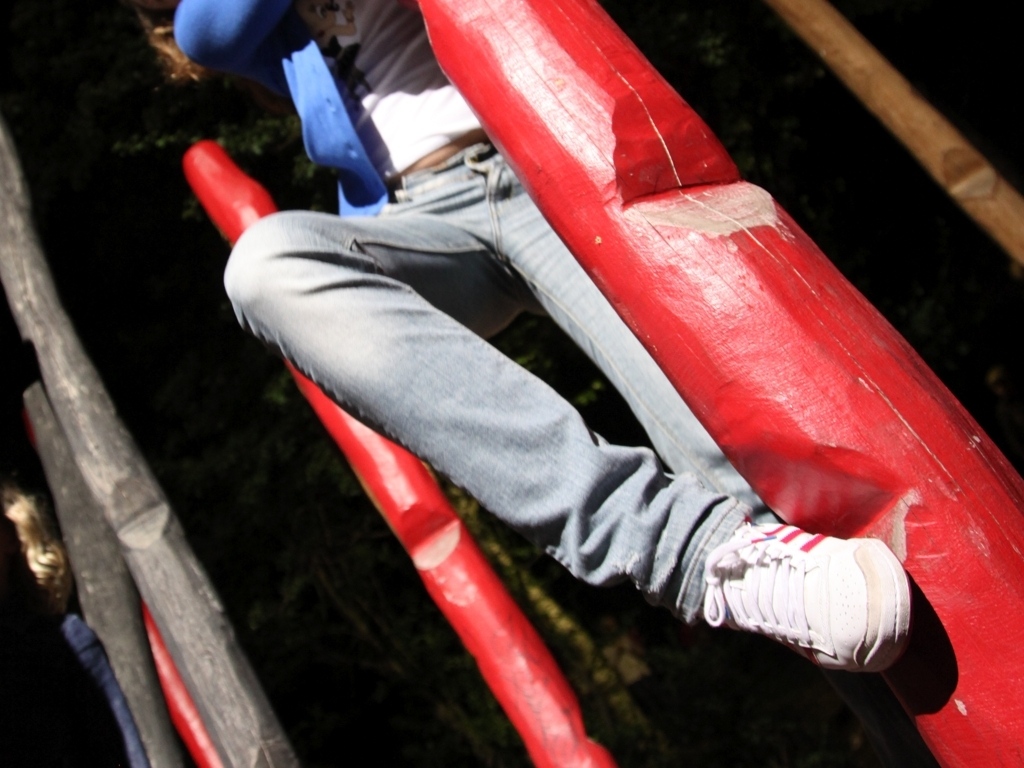What activity is being depicted in this image? The image captures a person in the midst of a dynamic outdoor activity, likely on a playground or an adventure course, grasping onto red bars which are part of the structure. 